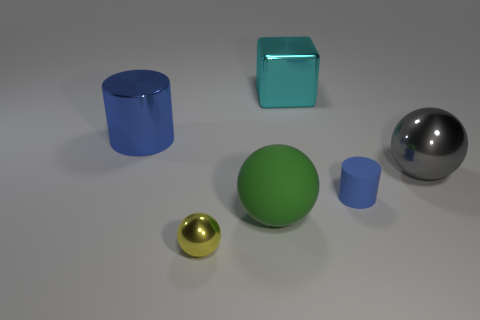Is the color of the large thing that is in front of the large gray metallic object the same as the small shiny thing?
Provide a succinct answer. No. Are there an equal number of big cyan shiny cubes that are behind the big cyan shiny object and big cyan cubes right of the gray thing?
Provide a short and direct response. Yes. Is there any other thing that is the same material as the yellow sphere?
Offer a very short reply. Yes. The metal object right of the cyan object is what color?
Offer a very short reply. Gray. Are there an equal number of large blue shiny objects that are in front of the tiny blue cylinder and small yellow things?
Provide a succinct answer. No. How many other things are there of the same shape as the cyan metal thing?
Your response must be concise. 0. There is a big blue cylinder; what number of big spheres are on the left side of it?
Offer a terse response. 0. How big is the object that is both on the right side of the large rubber object and to the left of the tiny matte object?
Keep it short and to the point. Large. Is there a tiny blue ball?
Give a very brief answer. No. How many other objects are there of the same size as the cube?
Make the answer very short. 3. 